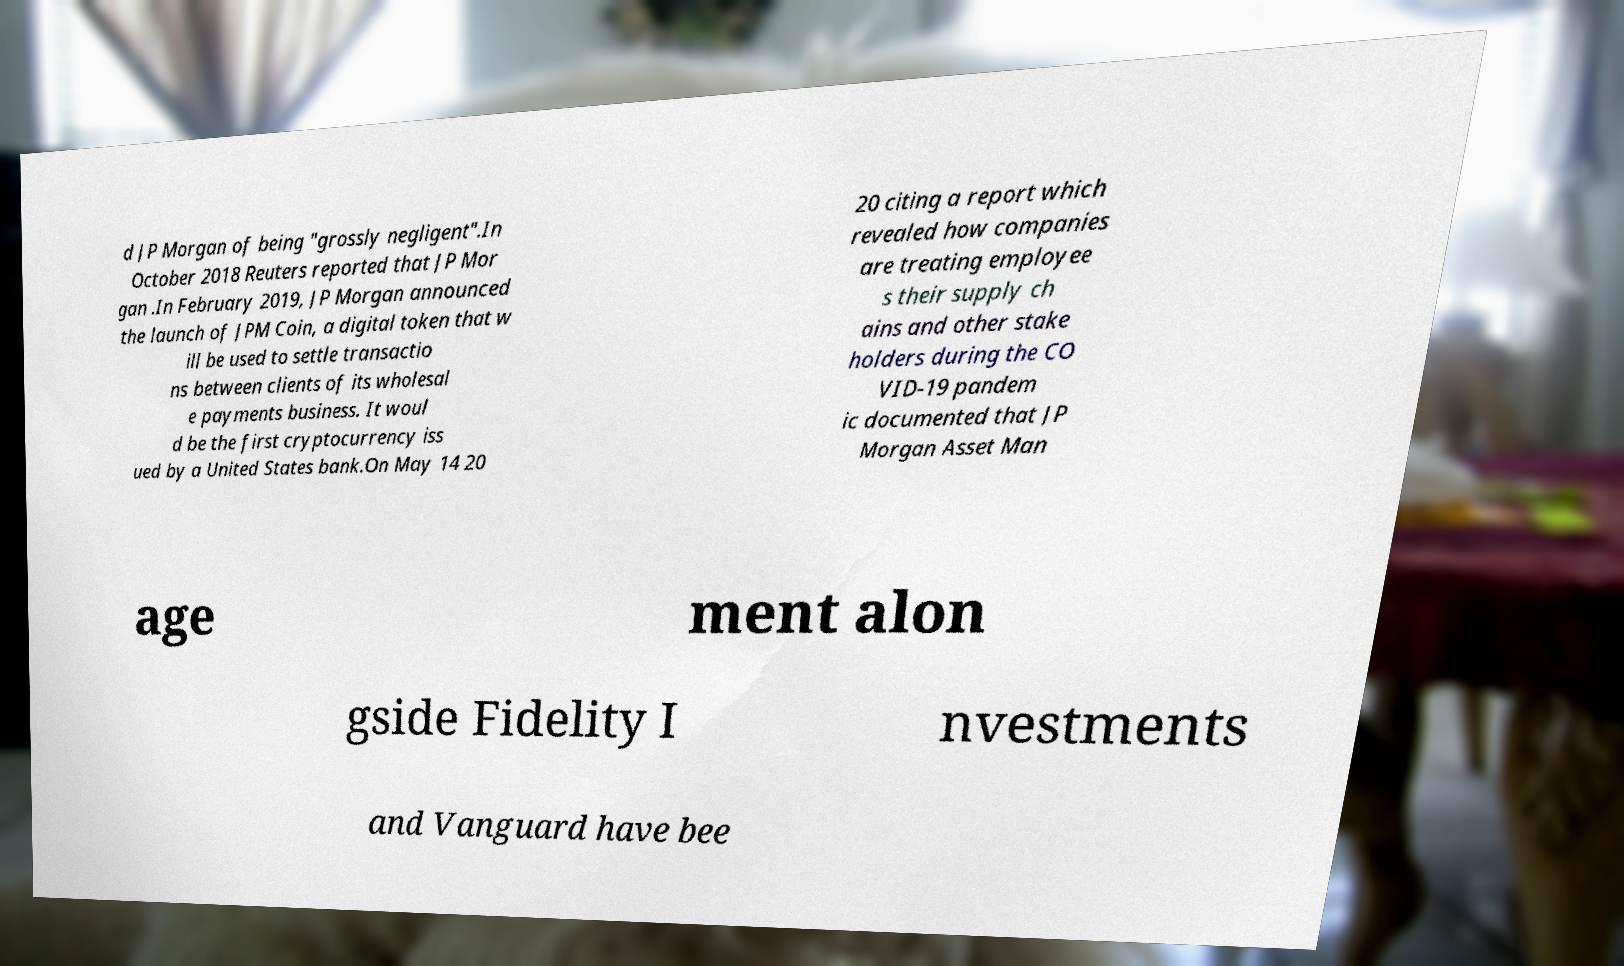I need the written content from this picture converted into text. Can you do that? d JP Morgan of being "grossly negligent".In October 2018 Reuters reported that JP Mor gan .In February 2019, JP Morgan announced the launch of JPM Coin, a digital token that w ill be used to settle transactio ns between clients of its wholesal e payments business. It woul d be the first cryptocurrency iss ued by a United States bank.On May 14 20 20 citing a report which revealed how companies are treating employee s their supply ch ains and other stake holders during the CO VID-19 pandem ic documented that JP Morgan Asset Man age ment alon gside Fidelity I nvestments and Vanguard have bee 